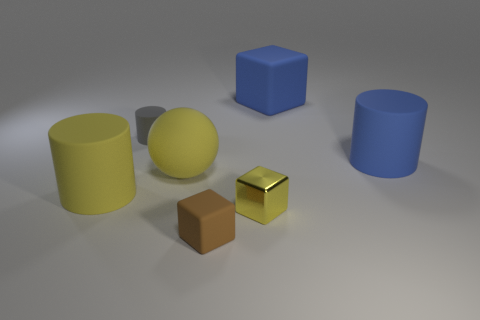Subtract all tiny yellow metallic cubes. How many cubes are left? 2 Add 1 purple rubber spheres. How many objects exist? 8 Subtract 1 blocks. How many blocks are left? 2 Subtract all spheres. How many objects are left? 6 Subtract 0 cyan cylinders. How many objects are left? 7 Subtract all gray blocks. Subtract all cyan spheres. How many blocks are left? 3 Subtract all gray objects. Subtract all gray rubber cylinders. How many objects are left? 5 Add 4 big spheres. How many big spheres are left? 5 Add 7 blue cylinders. How many blue cylinders exist? 8 